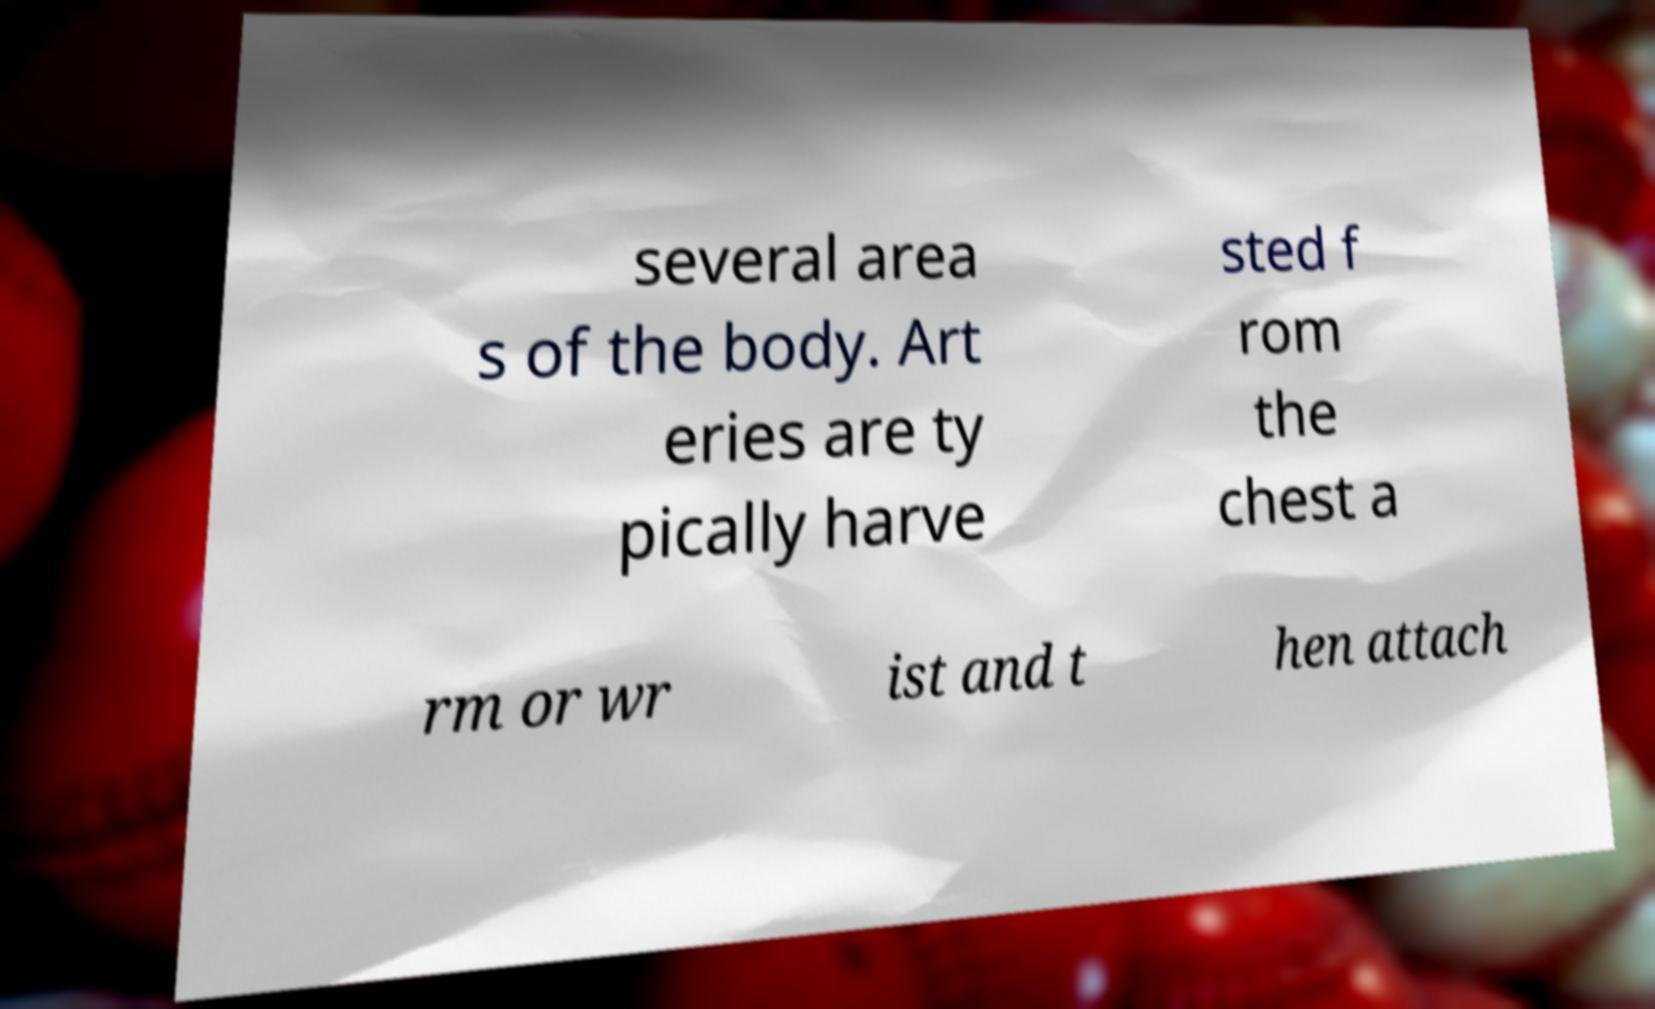Can you accurately transcribe the text from the provided image for me? several area s of the body. Art eries are ty pically harve sted f rom the chest a rm or wr ist and t hen attach 